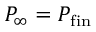<formula> <loc_0><loc_0><loc_500><loc_500>P _ { \infty } = P _ { f i n }</formula> 